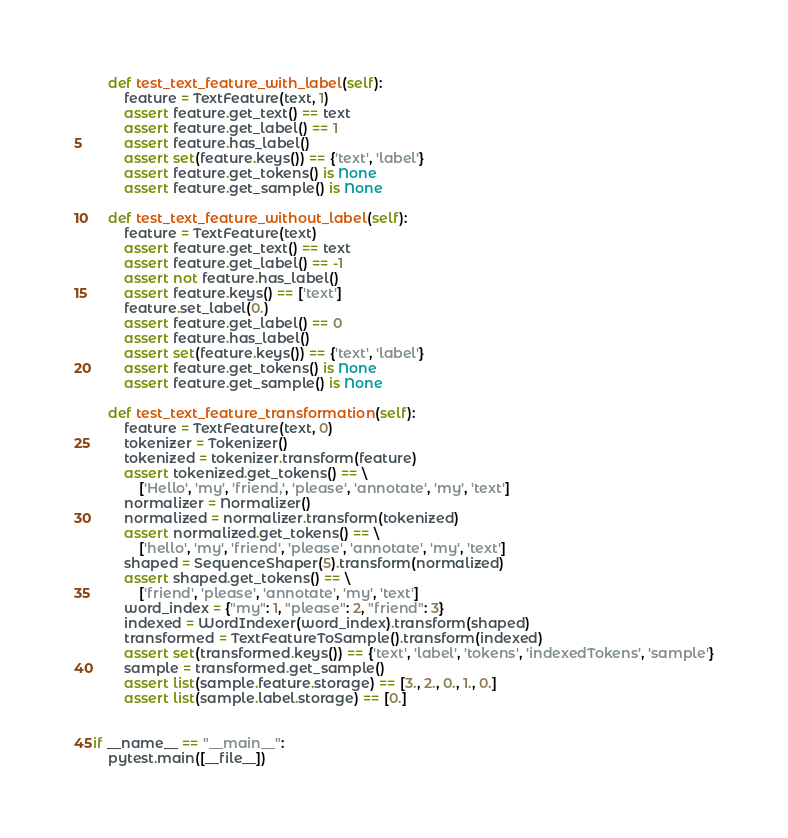Convert code to text. <code><loc_0><loc_0><loc_500><loc_500><_Python_>
    def test_text_feature_with_label(self):
        feature = TextFeature(text, 1)
        assert feature.get_text() == text
        assert feature.get_label() == 1
        assert feature.has_label()
        assert set(feature.keys()) == {'text', 'label'}
        assert feature.get_tokens() is None
        assert feature.get_sample() is None

    def test_text_feature_without_label(self):
        feature = TextFeature(text)
        assert feature.get_text() == text
        assert feature.get_label() == -1
        assert not feature.has_label()
        assert feature.keys() == ['text']
        feature.set_label(0.)
        assert feature.get_label() == 0
        assert feature.has_label()
        assert set(feature.keys()) == {'text', 'label'}
        assert feature.get_tokens() is None
        assert feature.get_sample() is None

    def test_text_feature_transformation(self):
        feature = TextFeature(text, 0)
        tokenizer = Tokenizer()
        tokenized = tokenizer.transform(feature)
        assert tokenized.get_tokens() == \
            ['Hello', 'my', 'friend,', 'please', 'annotate', 'my', 'text']
        normalizer = Normalizer()
        normalized = normalizer.transform(tokenized)
        assert normalized.get_tokens() == \
            ['hello', 'my', 'friend', 'please', 'annotate', 'my', 'text']
        shaped = SequenceShaper(5).transform(normalized)
        assert shaped.get_tokens() == \
            ['friend', 'please', 'annotate', 'my', 'text']
        word_index = {"my": 1, "please": 2, "friend": 3}
        indexed = WordIndexer(word_index).transform(shaped)
        transformed = TextFeatureToSample().transform(indexed)
        assert set(transformed.keys()) == {'text', 'label', 'tokens', 'indexedTokens', 'sample'}
        sample = transformed.get_sample()
        assert list(sample.feature.storage) == [3., 2., 0., 1., 0.]
        assert list(sample.label.storage) == [0.]


if __name__ == "__main__":
    pytest.main([__file__])
</code> 